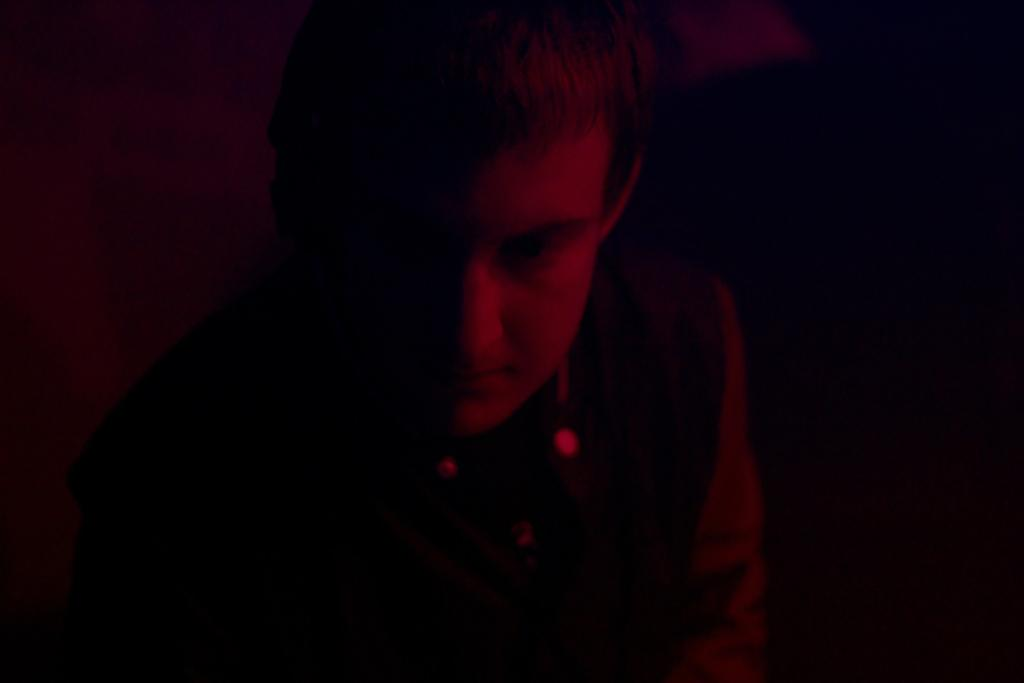What is the main subject in the foreground of the image? There is a person in the foreground of the image. What can be seen in the background of the image? There is a wall and some objects in the background of the image. What type of riddle can be seen on the person's toe in the image? There is no riddle or any reference to a person's toe in the image. 